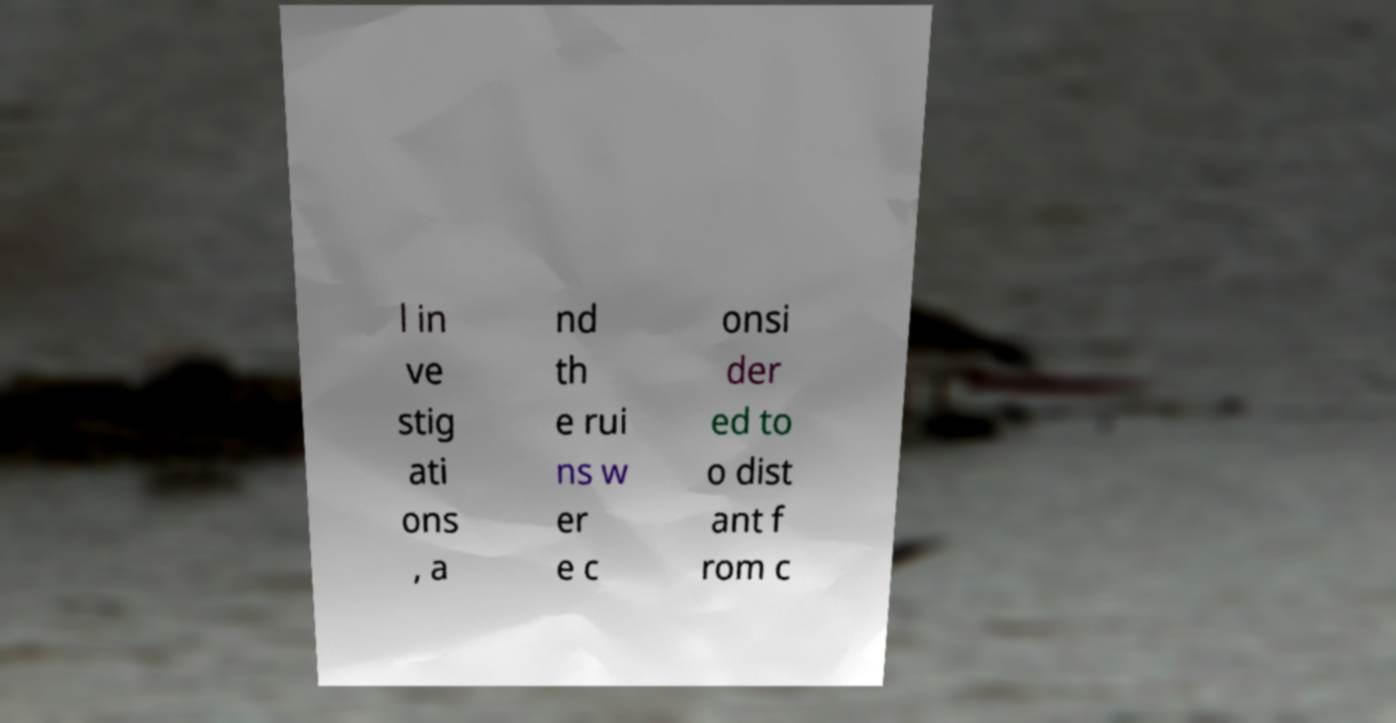Can you accurately transcribe the text from the provided image for me? l in ve stig ati ons , a nd th e rui ns w er e c onsi der ed to o dist ant f rom c 